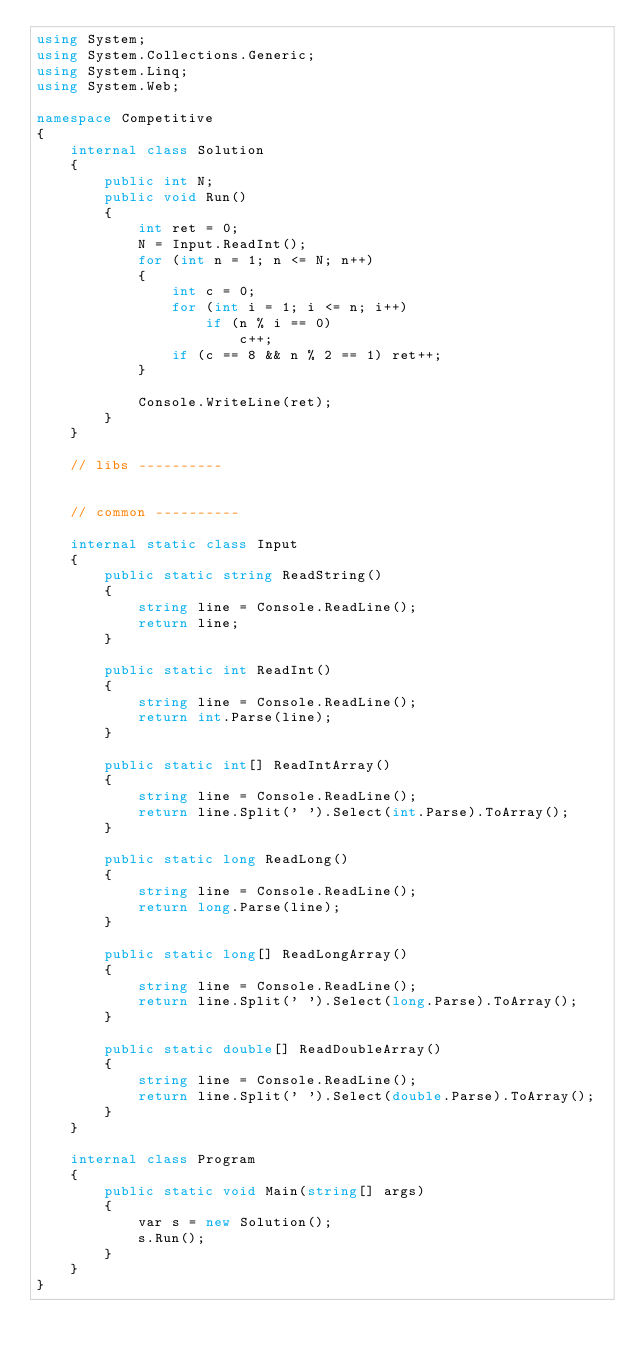Convert code to text. <code><loc_0><loc_0><loc_500><loc_500><_C#_>using System;
using System.Collections.Generic;
using System.Linq;
using System.Web;

namespace Competitive
{
    internal class Solution
    {
        public int N;
        public void Run()
        {
            int ret = 0;
            N = Input.ReadInt();
            for (int n = 1; n <= N; n++)
            {
                int c = 0;
                for (int i = 1; i <= n; i++)
                    if (n % i == 0)
                        c++;
                if (c == 8 && n % 2 == 1) ret++;
            }

            Console.WriteLine(ret);
        }
    }

    // libs ----------


    // common ----------

    internal static class Input
    {
        public static string ReadString()
        {
            string line = Console.ReadLine();
            return line;
        }

        public static int ReadInt()
        {
            string line = Console.ReadLine();
            return int.Parse(line);
        }

        public static int[] ReadIntArray()
        {
            string line = Console.ReadLine();
            return line.Split(' ').Select(int.Parse).ToArray();
        }

        public static long ReadLong()
        {
            string line = Console.ReadLine();
            return long.Parse(line);
        }

        public static long[] ReadLongArray()
        {
            string line = Console.ReadLine();
            return line.Split(' ').Select(long.Parse).ToArray();
        }

        public static double[] ReadDoubleArray()
        {
            string line = Console.ReadLine();
            return line.Split(' ').Select(double.Parse).ToArray();
        }
    }

    internal class Program
    {
        public static void Main(string[] args)
        {
            var s = new Solution();
            s.Run();
        }
    }
}</code> 